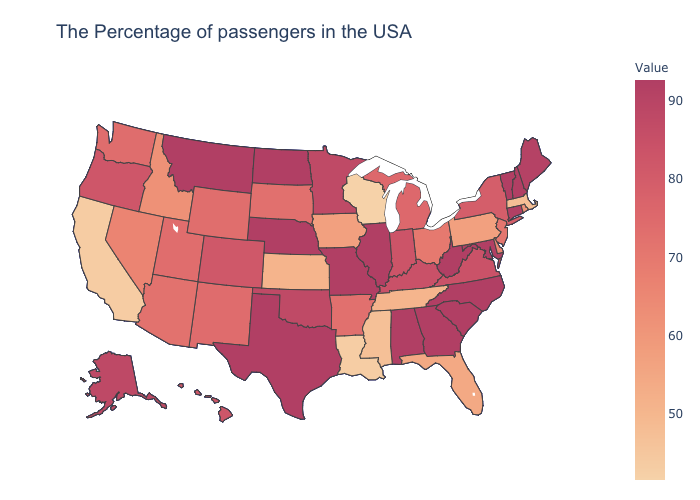Is the legend a continuous bar?
Quick response, please. Yes. Does South Carolina have a lower value than Rhode Island?
Be succinct. No. Does Arizona have a lower value than Wisconsin?
Quick response, please. No. Among the states that border Oklahoma , does Kansas have the highest value?
Answer briefly. No. Does New Mexico have a lower value than Virginia?
Short answer required. Yes. Which states have the highest value in the USA?
Be succinct. New Hampshire, Vermont, Connecticut, Maryland, North Carolina, South Carolina, West Virginia, Georgia, Alabama, Illinois, Missouri, Nebraska, Texas, North Dakota, Montana. Which states have the highest value in the USA?
Write a very short answer. New Hampshire, Vermont, Connecticut, Maryland, North Carolina, South Carolina, West Virginia, Georgia, Alabama, Illinois, Missouri, Nebraska, Texas, North Dakota, Montana. 